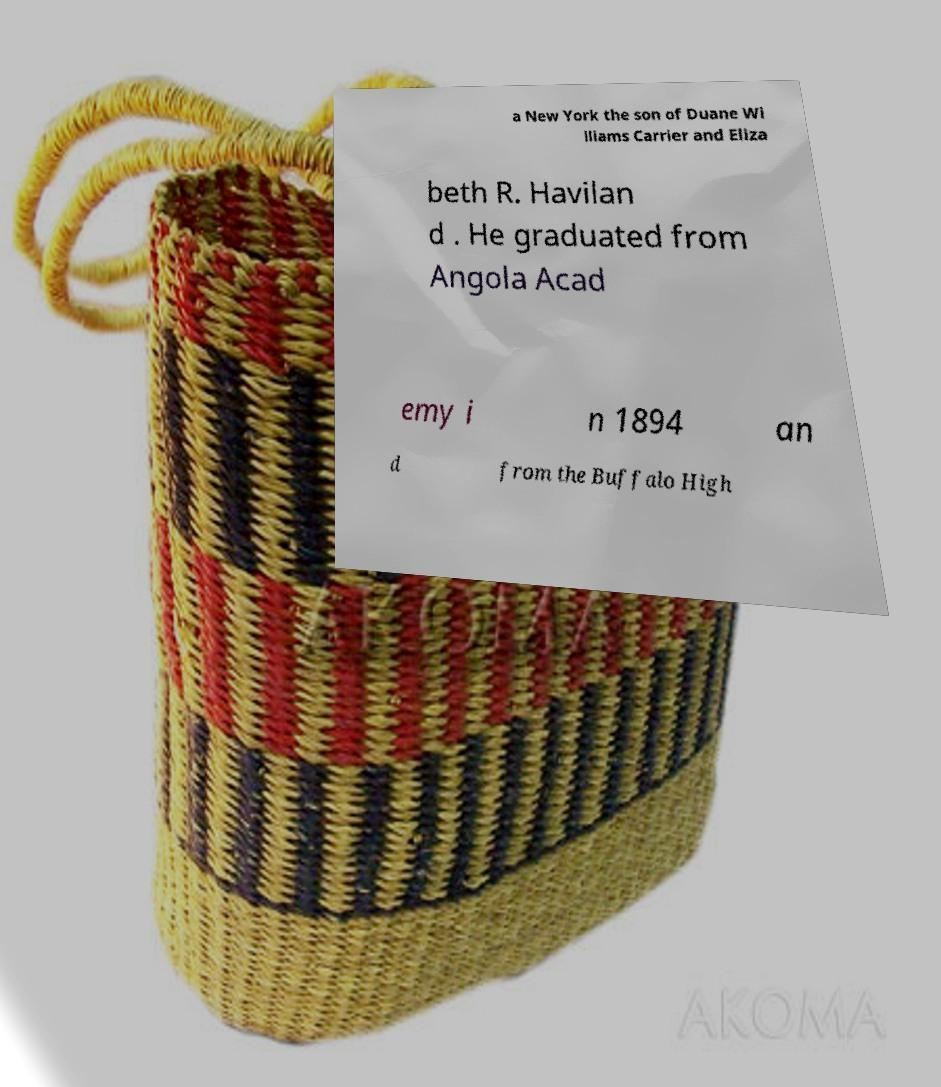What messages or text are displayed in this image? I need them in a readable, typed format. a New York the son of Duane Wi lliams Carrier and Eliza beth R. Havilan d . He graduated from Angola Acad emy i n 1894 an d from the Buffalo High 